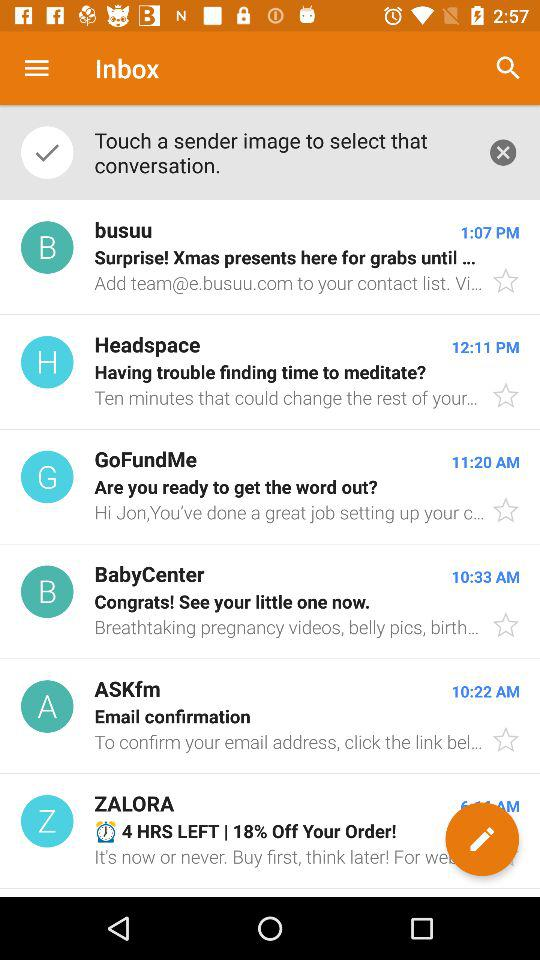Which email was sent at 4:31 PM?
When the provided information is insufficient, respond with <no answer>. <no answer> 